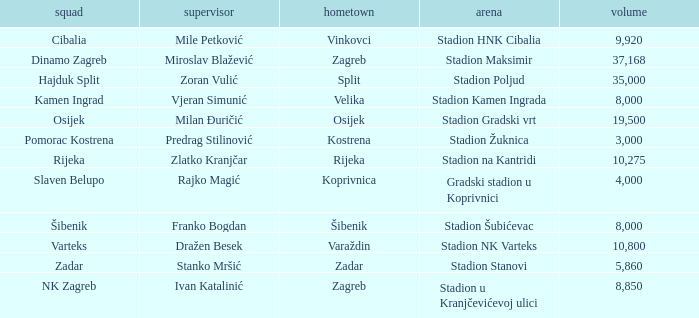What team has a home city of Koprivnica? Slaven Belupo. 